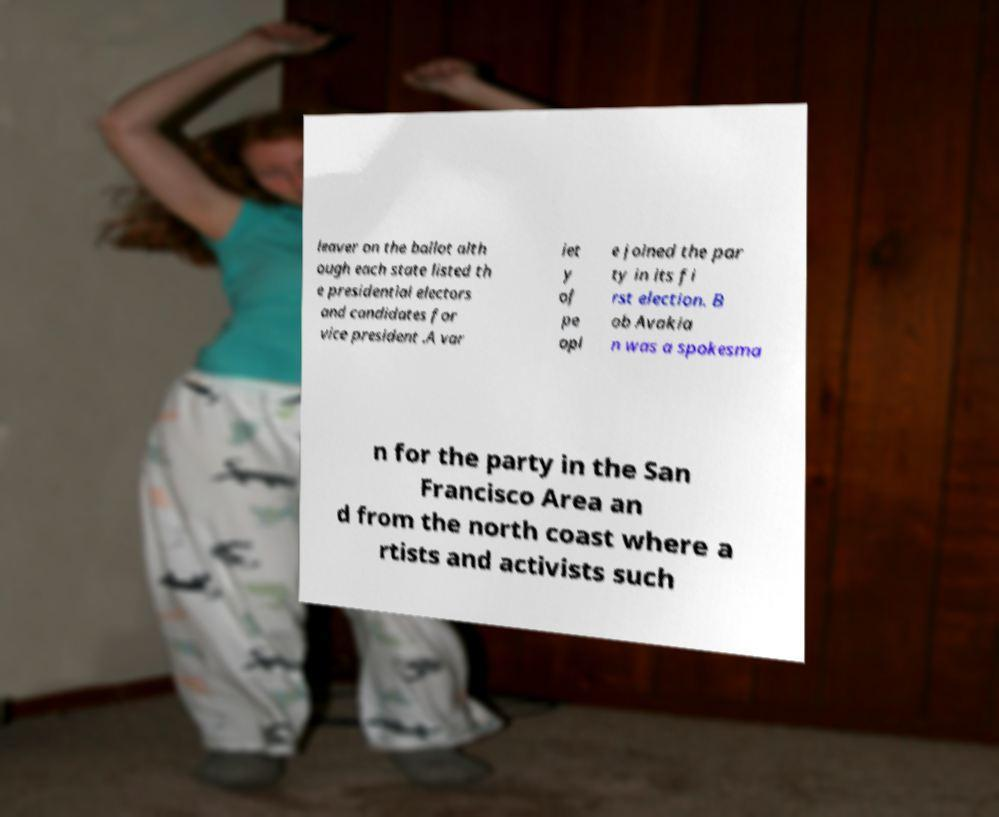Could you extract and type out the text from this image? leaver on the ballot alth ough each state listed th e presidential electors and candidates for vice president .A var iet y of pe opl e joined the par ty in its fi rst election. B ob Avakia n was a spokesma n for the party in the San Francisco Area an d from the north coast where a rtists and activists such 